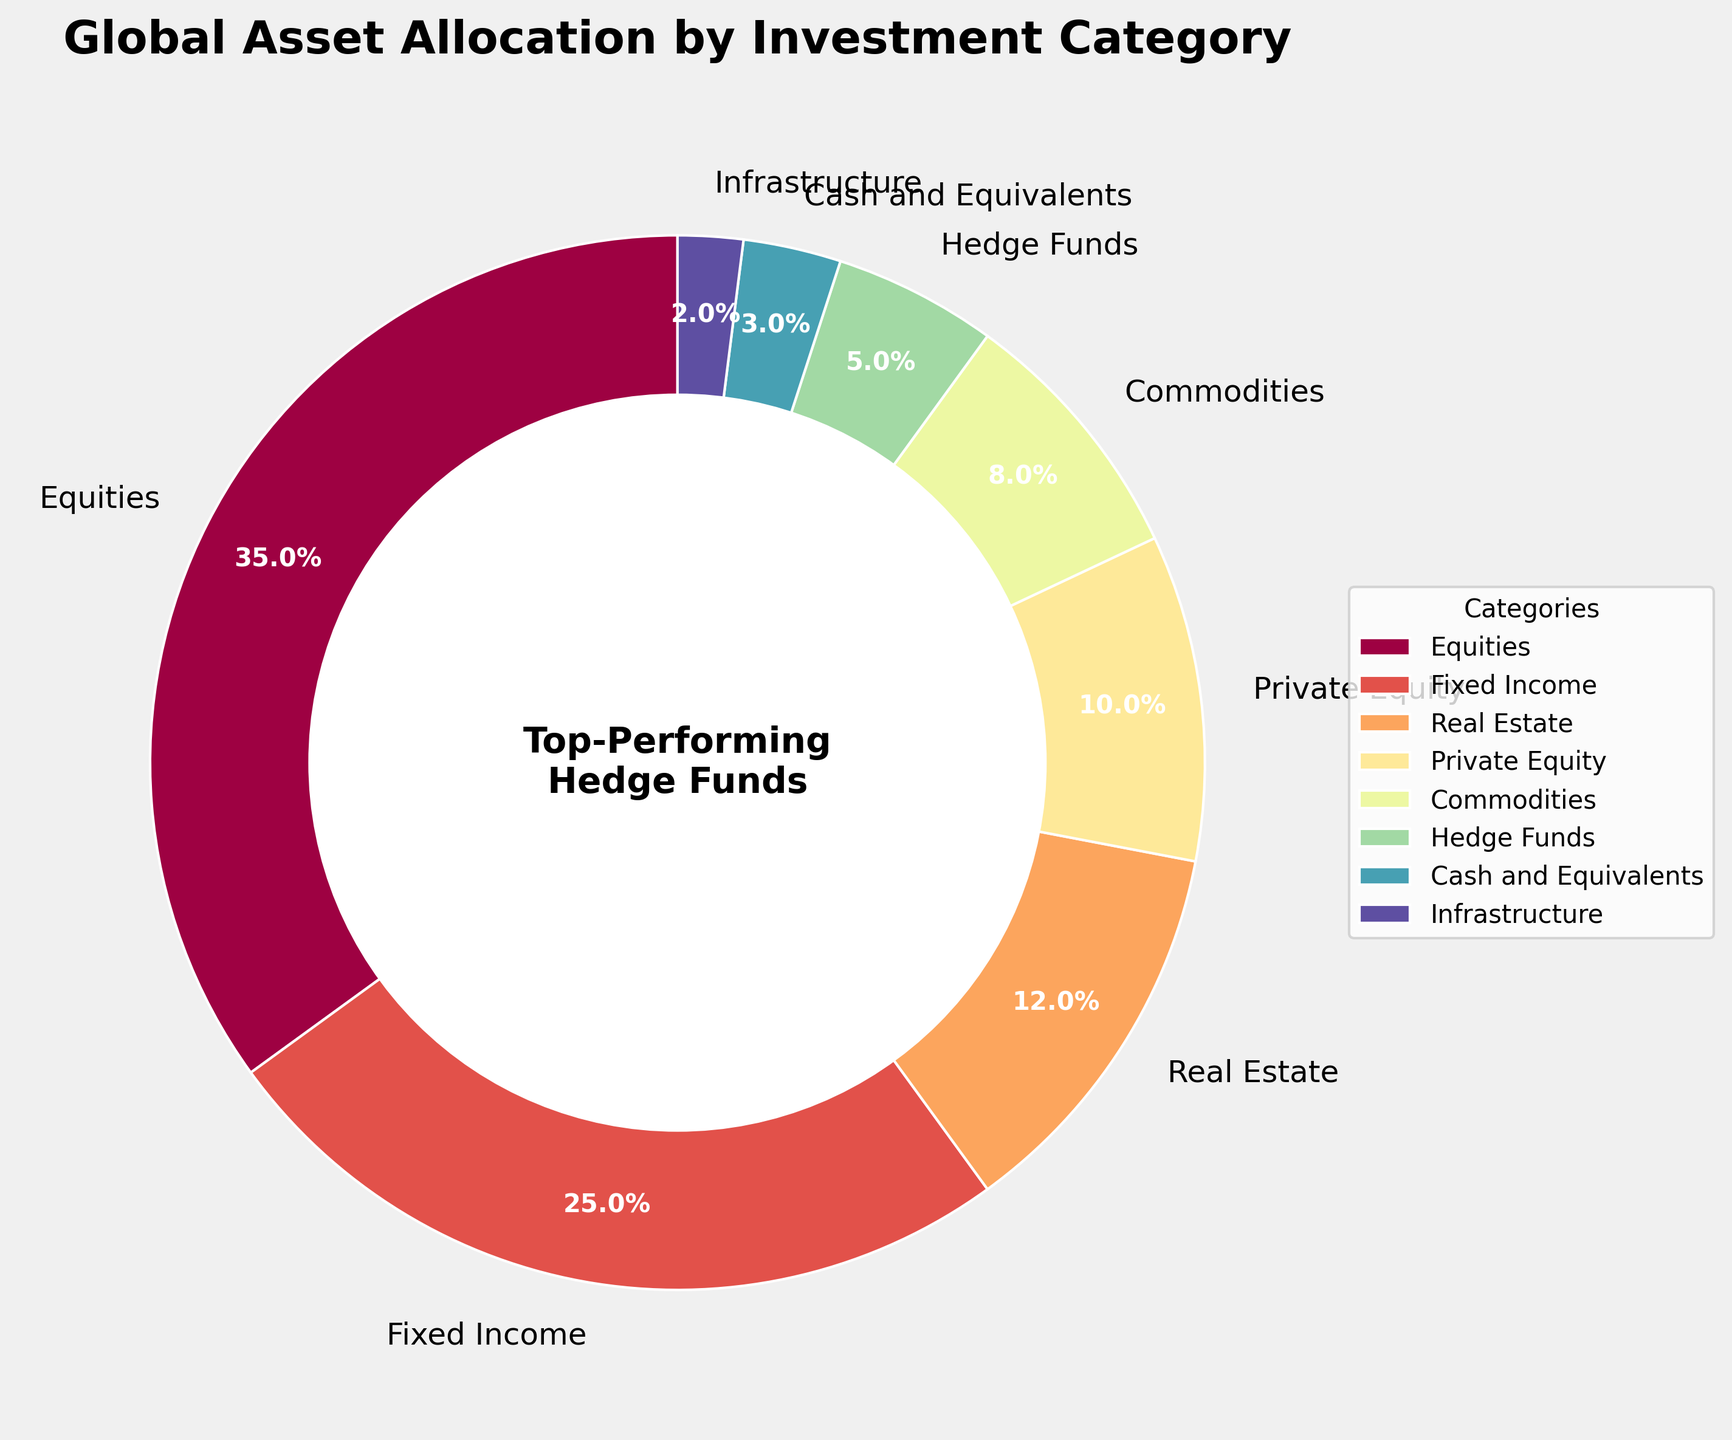Which investment category has the highest allocation percentage? The pie chart shows that Equities have the largest segment, indicated by the size of the segment and the percentage label.
Answer: Equities What is the combined allocation percentage of Real Estate and Private Equity? According to the figure, Real Estate is 12% and Private Equity is 10%. Adding them together gives 12% + 10% = 22%.
Answer: 22% How does the allocation of Fixed Income compare to Commodities? The allocation for Fixed Income is 25%, whereas for Commodities it is 8%. 25% is significantly higher than 8%.
Answer: Fixed Income is higher Which categories have an allocation of less than 10%? By inspecting the pie chart, Private Equity (10%), Commodities (8%), Hedge Funds (5%), Cash and Equivalents (3%), and Infrastructure (2%) are the categories.
Answer: Commodities, Hedge Funds, Cash and Equivalents, and Infrastructure What is the color associated with Real Estate in the pie chart? Real Estate is represented in the pie chart by examining the legend.
Answer: Orange If Equities and Fixed Income allocations are combined, what would their total percentage be out of the overall allocation? Equities have 35% and Fixed Income has 25%. Thus, their combined allocation is 35% + 25% = 60%.
Answer: 60% How does the percentage allocation of Cash and Equivalents compare to Infrastructure? Cash and Equivalents have an allocation of 3%, while Infrastructure has an allocation of 2%, 3% is slightly higher than 2%.
Answer: Cash and Equivalents is higher What fraction of the total allocation does Hedge Funds represent when combined with Equities and Private Equity? Equities (35%), Private Equity (10%), and Hedge Funds (5%). Their combined sum is 35% + 10% + 5% = 50%. To convert this into a fraction out of 100%, we get 50/100 = 1/2.
Answer: 1/2 What is the difference in percentage allocation between the categories with the highest and lowest allocations? Equities have the highest allocation at 35%, and Infrastructure has the lowest at 2%. The difference is 35% - 2% = 33%.
Answer: 33% What percentage of the total allocation is represented by categories other than Equities, Fixed Income, and Real Estate? The percentages for categories other than Equities (35%), Fixed Income (25%), and Real Estate (12%) are Private Equity (10%), Commodities (8%), Hedge Funds (5%), Cash and Equivalents (3%), and Infrastructure (2%). Adding these gives 10% + 8% + 5% + 3% + 2% = 28%.
Answer: 28% 